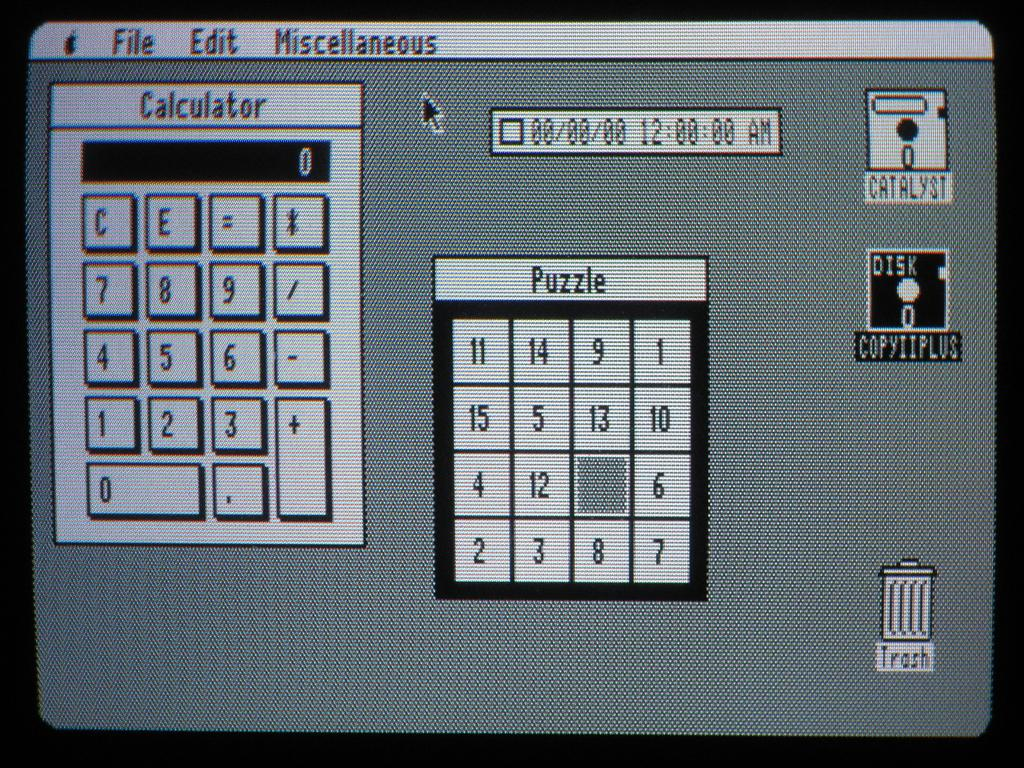<image>
Offer a succinct explanation of the picture presented. A screen shows a Calculator on the left and a puzzle on the right. 